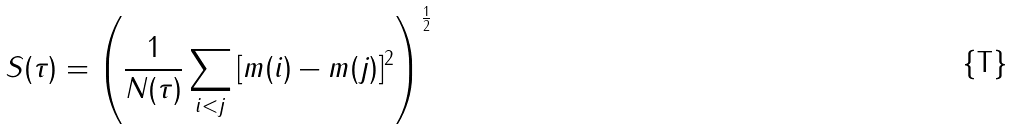Convert formula to latex. <formula><loc_0><loc_0><loc_500><loc_500>S ( \tau ) = \left ( \frac { 1 } { N ( \tau ) } \sum _ { i < j } { [ m ( i ) - m ( j ) ] ^ { 2 } } \right ) ^ { \frac { 1 } { 2 } }</formula> 